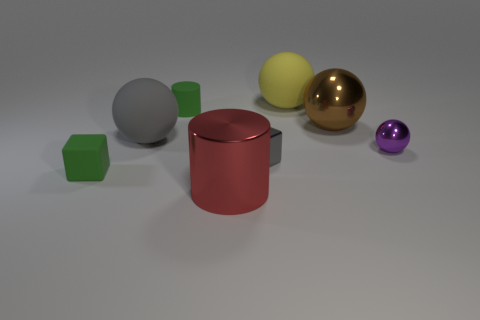The small block behind the cube to the left of the large cylinder that is in front of the tiny green rubber block is made of what material? metal 